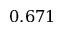<formula> <loc_0><loc_0><loc_500><loc_500>0 . 6 7 1</formula> 